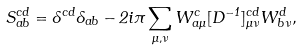Convert formula to latex. <formula><loc_0><loc_0><loc_500><loc_500>S _ { a b } ^ { c d } = \delta ^ { c d } \delta _ { a b } - 2 i \pi \sum _ { \mu , \nu } W _ { a \mu } ^ { c } [ D ^ { - 1 } ] _ { \mu \nu } ^ { c d } W _ { b \nu } ^ { d } ,</formula> 